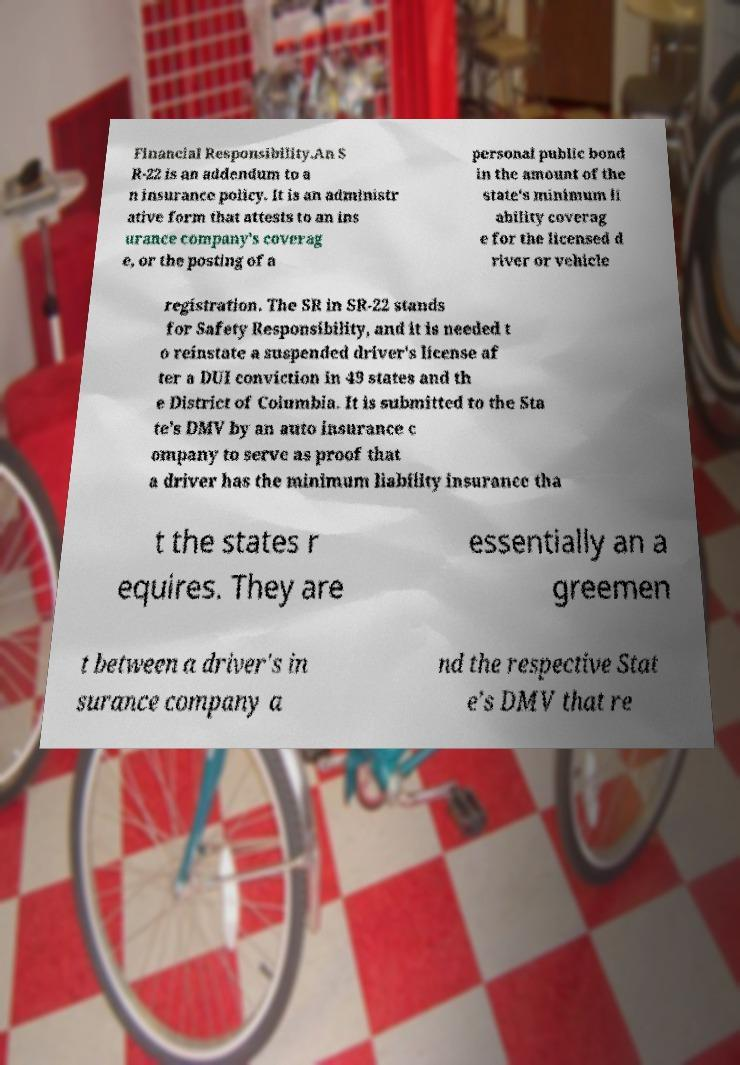I need the written content from this picture converted into text. Can you do that? Financial Responsibility.An S R-22 is an addendum to a n insurance policy. It is an administr ative form that attests to an ins urance company's coverag e, or the posting of a personal public bond in the amount of the state's minimum li ability coverag e for the licensed d river or vehicle registration. The SR in SR-22 stands for Safety Responsibility, and it is needed t o reinstate a suspended driver's license af ter a DUI conviction in 49 states and th e District of Columbia. It is submitted to the Sta te's DMV by an auto insurance c ompany to serve as proof that a driver has the minimum liability insurance tha t the states r equires. They are essentially an a greemen t between a driver's in surance company a nd the respective Stat e's DMV that re 